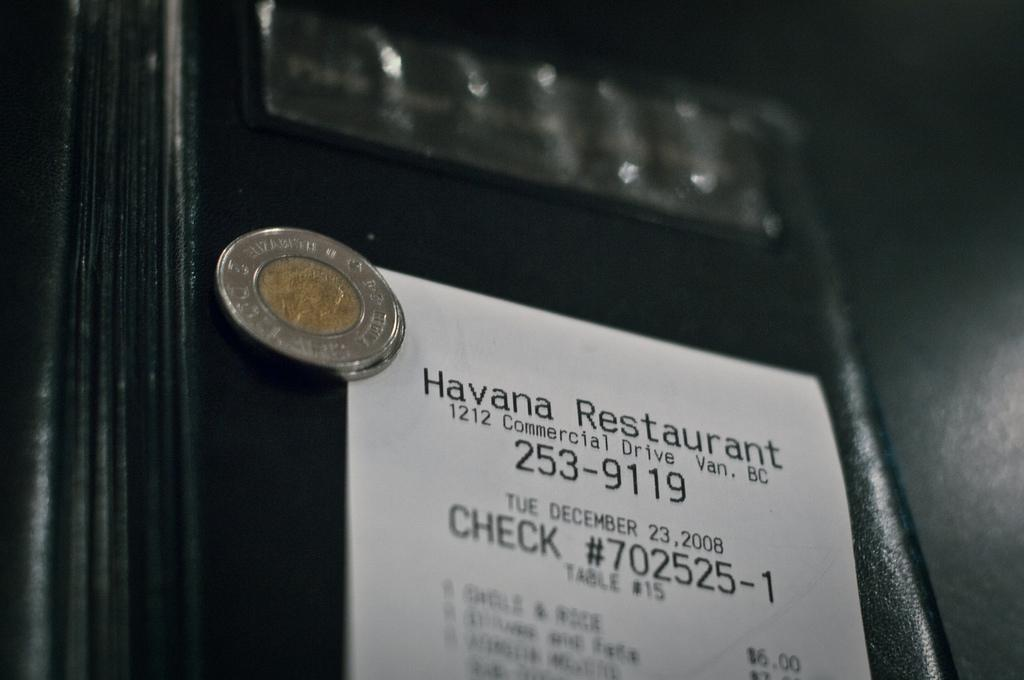<image>
Relay a brief, clear account of the picture shown. The restaurant receipe shows the restaurant is located at 1212 Commercial Drive. 